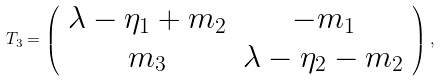<formula> <loc_0><loc_0><loc_500><loc_500>T _ { 3 } = \left ( \begin{array} { c c } \lambda - \eta _ { 1 } + m _ { 2 } & - m _ { 1 } \\ m _ { 3 } & \lambda - \eta _ { 2 } - m _ { 2 } \end{array} \right ) ,</formula> 